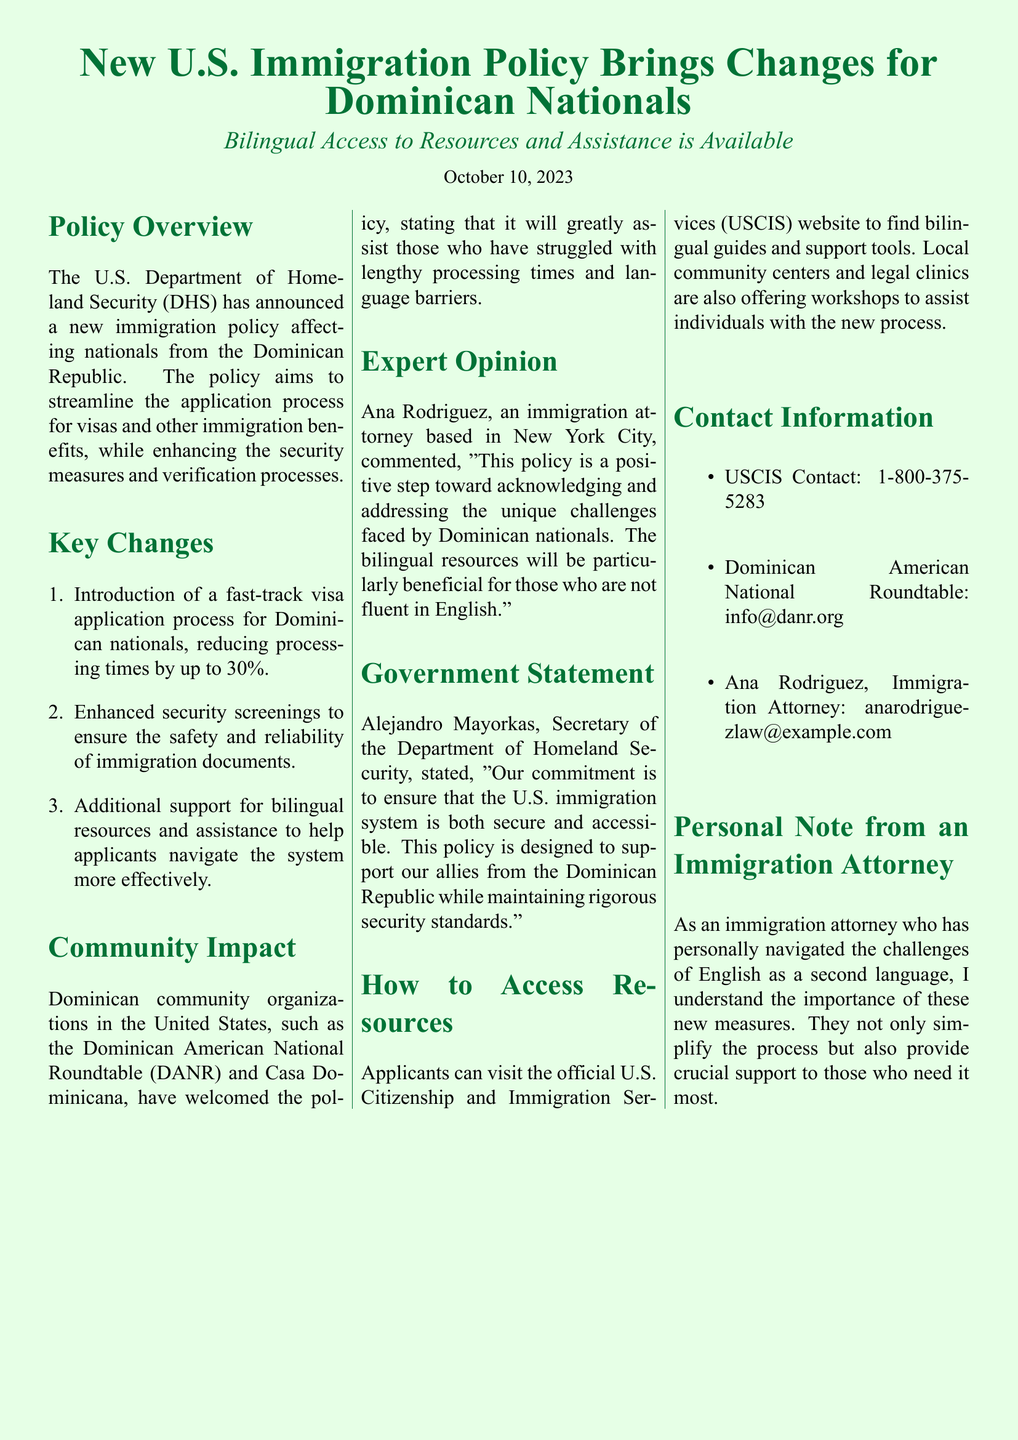What is the date of the announcement? The date mentioned in the document for the announcement is October 10, 2023.
Answer: October 10, 2023 Who commented on the policy as an immigration attorney? The document states that Ana Rodriguez, an immigration attorney based in New York City, commented on the policy.
Answer: Ana Rodriguez What is the maximum percentage by which processing times will be reduced? The document indicates that processing times will be reduced by up to 30%.
Answer: 30% Which organization is mentioned as supporting the new policy? The Dominican American National Roundtable (DANR) is mentioned as welcoming the policy.
Answer: Dominican American National Roundtable (DANR) What type of resources will be available for applicants? The document specifies that bilingual resources and assistance will be available to help applicants navigate the system.
Answer: Bilingual resources and assistance Who is the Secretary of the Department of Homeland Security? Alejandro Mayorkas is identified as the Secretary of the Department of Homeland Security in the document.
Answer: Alejandro Mayorkas What is the contact number for USCIS? The USCIS contact number provided in the document is 1-800-375-5283.
Answer: 1-800-375-5283 How does the document describe the new immigration policy? The document describes the new immigration policy as a positive step toward addressing unique challenges faced by Dominican nationals.
Answer: A positive step toward addressing unique challenges 